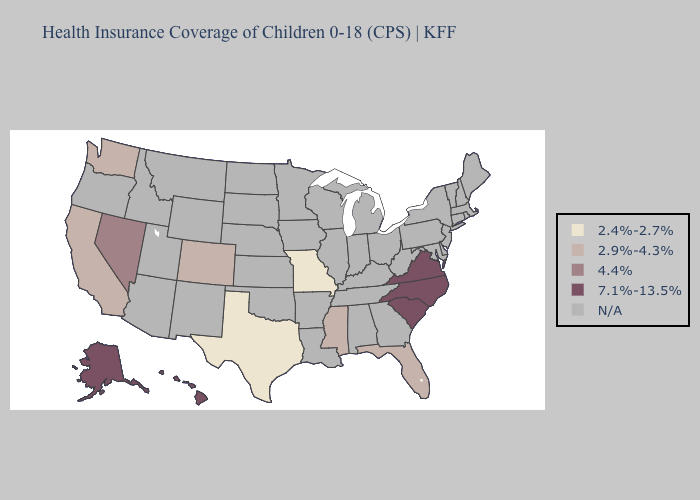What is the value of Florida?
Give a very brief answer. 2.9%-4.3%. Which states hav the highest value in the MidWest?
Answer briefly. Missouri. What is the value of Nevada?
Write a very short answer. 4.4%. What is the highest value in the West ?
Give a very brief answer. 7.1%-13.5%. Which states have the lowest value in the USA?
Short answer required. Missouri, Texas. Name the states that have a value in the range N/A?
Quick response, please. Alabama, Arizona, Arkansas, Connecticut, Delaware, Georgia, Idaho, Illinois, Indiana, Iowa, Kansas, Kentucky, Louisiana, Maine, Maryland, Massachusetts, Michigan, Minnesota, Montana, Nebraska, New Hampshire, New Jersey, New Mexico, New York, North Dakota, Ohio, Oklahoma, Oregon, Pennsylvania, Rhode Island, South Dakota, Tennessee, Utah, Vermont, West Virginia, Wisconsin, Wyoming. Name the states that have a value in the range 2.4%-2.7%?
Quick response, please. Missouri, Texas. What is the value of Hawaii?
Answer briefly. 7.1%-13.5%. Does the first symbol in the legend represent the smallest category?
Write a very short answer. Yes. 